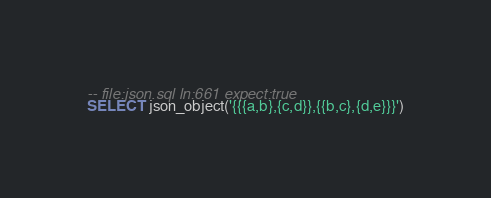Convert code to text. <code><loc_0><loc_0><loc_500><loc_500><_SQL_>-- file:json.sql ln:661 expect:true
SELECT json_object('{{{a,b},{c,d}},{{b,c},{d,e}}}')
</code> 